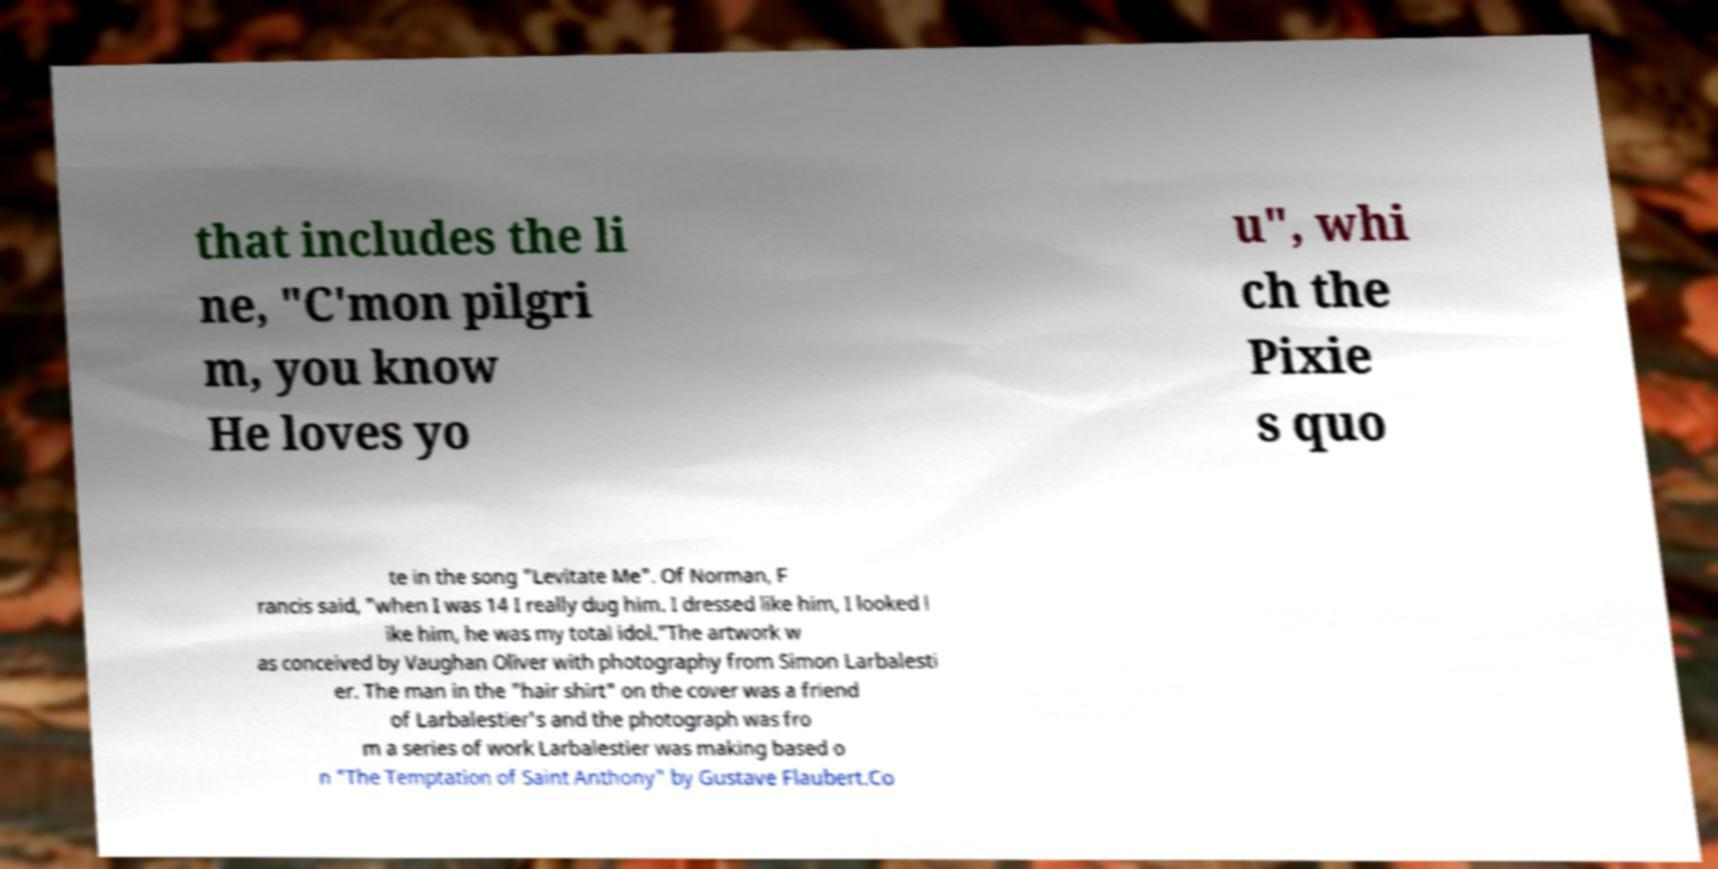There's text embedded in this image that I need extracted. Can you transcribe it verbatim? that includes the li ne, "C'mon pilgri m, you know He loves yo u", whi ch the Pixie s quo te in the song "Levitate Me". Of Norman, F rancis said, "when I was 14 I really dug him. I dressed like him, I looked l ike him, he was my total idol."The artwork w as conceived by Vaughan Oliver with photography from Simon Larbalesti er. The man in the "hair shirt" on the cover was a friend of Larbalestier's and the photograph was fro m a series of work Larbalestier was making based o n "The Temptation of Saint Anthony" by Gustave Flaubert.Co 